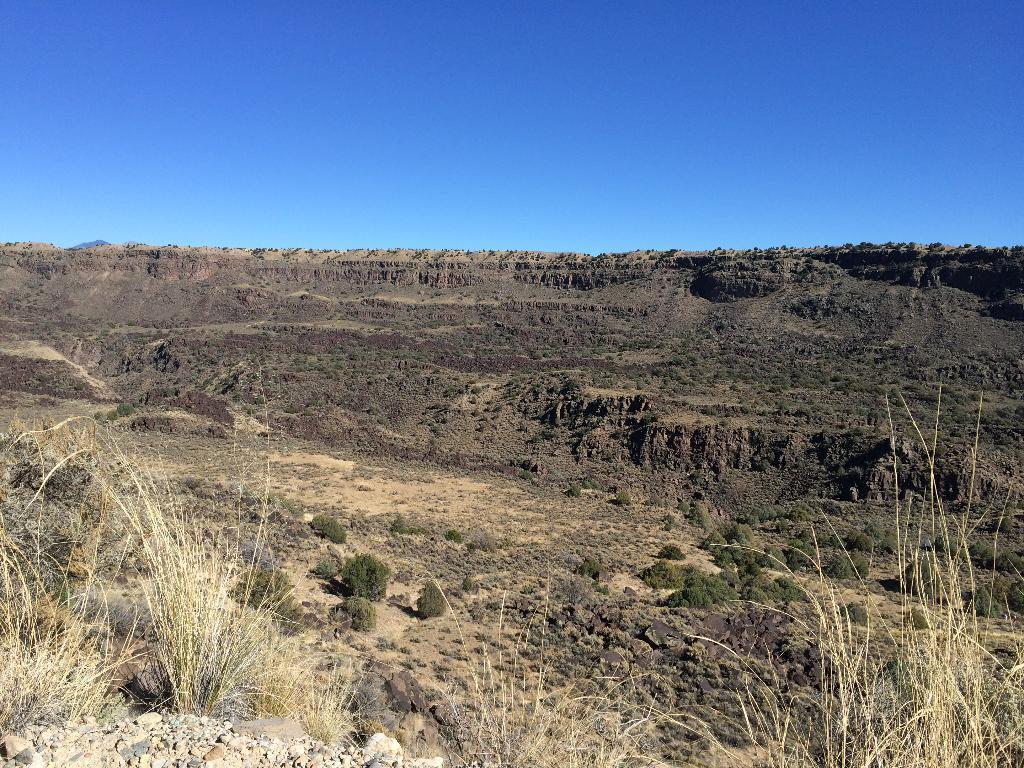What type of vegetation can be seen in the image? There are plants and grass in the image. What other objects can be seen in the image besides vegetation? There are stones in the image. What is visible at the top of the image? The sky is clear and visible at the top of the image. How many teeth can be seen in the image? There are no teeth present in the image. What type of wood is used to construct the fence in the image? There is no fence present in the image, so it is not possible to determine the type of wood used. 